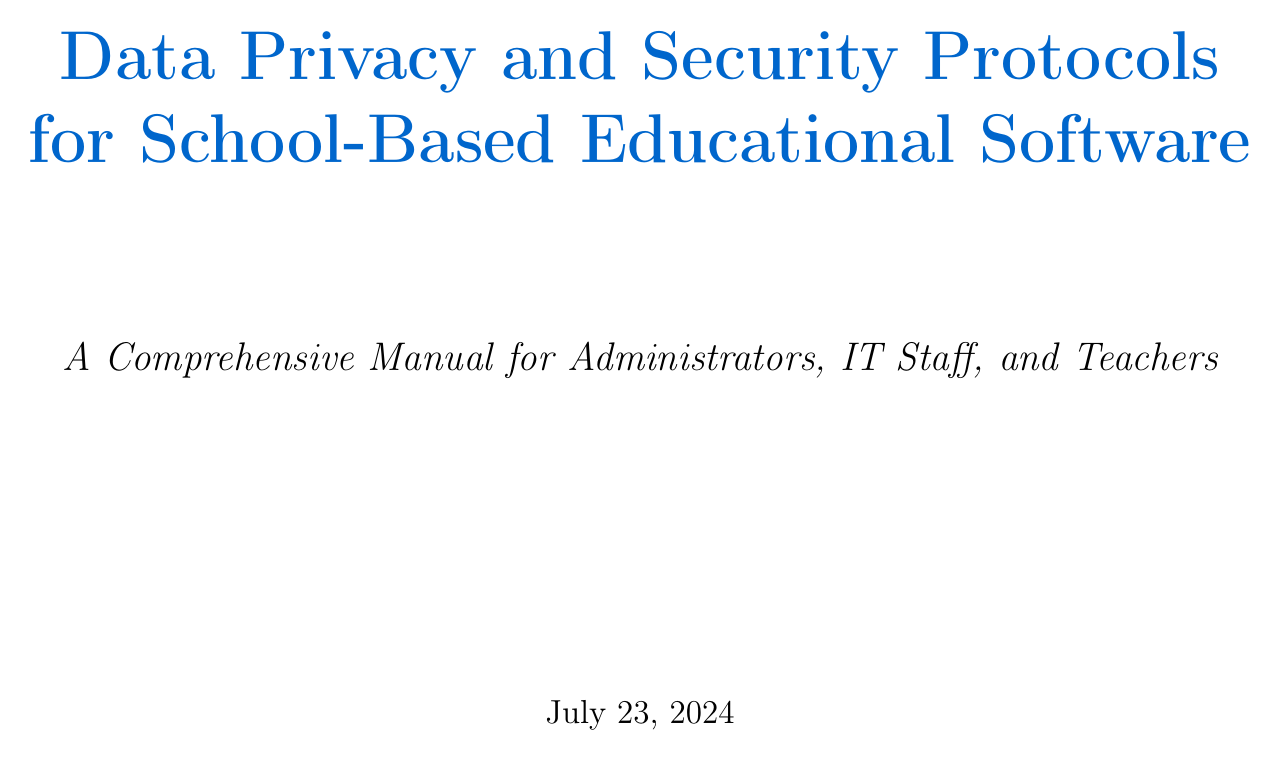What is the manual title? The manual title is stated at the beginning of the document as "Data Privacy and Security Protocols for School-Based Educational Software".
Answer: Data Privacy and Security Protocols for School-Based Educational Software Who is the target audience? The target audience is mentioned in the introduction section, specifically stating "School administrators, IT staff, and teachers using our educational software products".
Answer: School administrators, IT staff, and teachers What act does FERPA stand for? The section on FERPA compliance indicates it stands for the Family Educational Rights and Privacy Act.
Answer: Family Educational Rights and Privacy Act What type of encryption is mentioned for data transmission? The document specifies that TLS 1.3 is used for all data transmissions.
Answer: TLS 1.3 How often are privacy impact assessments conducted? The manual notes that privacy impact assessments are conducted annually.
Answer: Annual What is the purpose of employee training? The employee training aims to raise awareness of security issues as stated in the relevant section.
Answer: Security awareness training What issue does the document cover that's related to data breaches? The document provides a step-by-step guide for handling potential data breaches.
Answer: Data breaches What tool is used for phishing simulation exercises? The manual mentions the KnowBe4 platform for conducting phishing simulation exercises.
Answer: KnowBe4 What security feature does the software implement for user authentication? The document discusses the implementation of Single Sign-On (SSO) for user authentication.
Answer: Single Sign-On (SSO) 